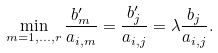<formula> <loc_0><loc_0><loc_500><loc_500>\min _ { m = 1 , \dots , r } \frac { b _ { m } ^ { \prime } } { a _ { i , m } } = \frac { b _ { j } ^ { \prime } } { a _ { i , j } } = \lambda \frac { b _ { j } } { a _ { i , j } } .</formula> 